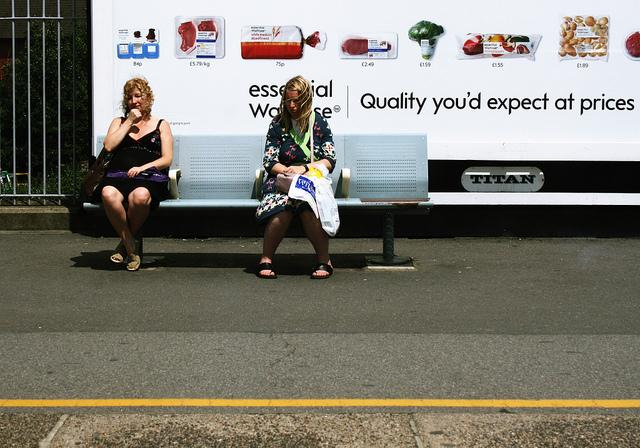What is the large object trying to get you to do? shop 